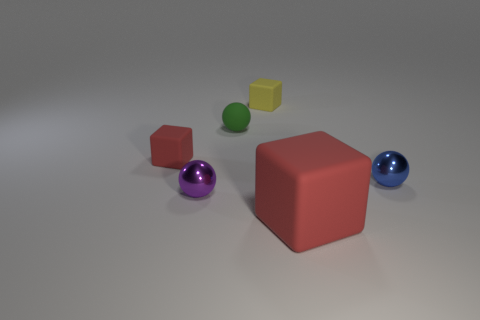Is the shape of the large red matte thing the same as the yellow matte thing?
Provide a succinct answer. Yes. There is a green matte thing that is the same shape as the purple object; what is its size?
Your response must be concise. Small. Does the red object that is to the left of the green object have the same size as the large object?
Provide a succinct answer. No. How big is the thing that is both behind the purple sphere and right of the tiny yellow thing?
Your response must be concise. Small. What material is the object that is the same color as the big matte block?
Your answer should be very brief. Rubber. How many matte balls are the same color as the big object?
Your answer should be very brief. 0. Is the number of blocks in front of the tiny yellow rubber object the same as the number of big red things?
Offer a terse response. No. What is the color of the big rubber thing?
Your answer should be compact. Red. What size is the green sphere that is made of the same material as the yellow object?
Ensure brevity in your answer.  Small. What color is the small sphere that is made of the same material as the blue object?
Your response must be concise. Purple. 